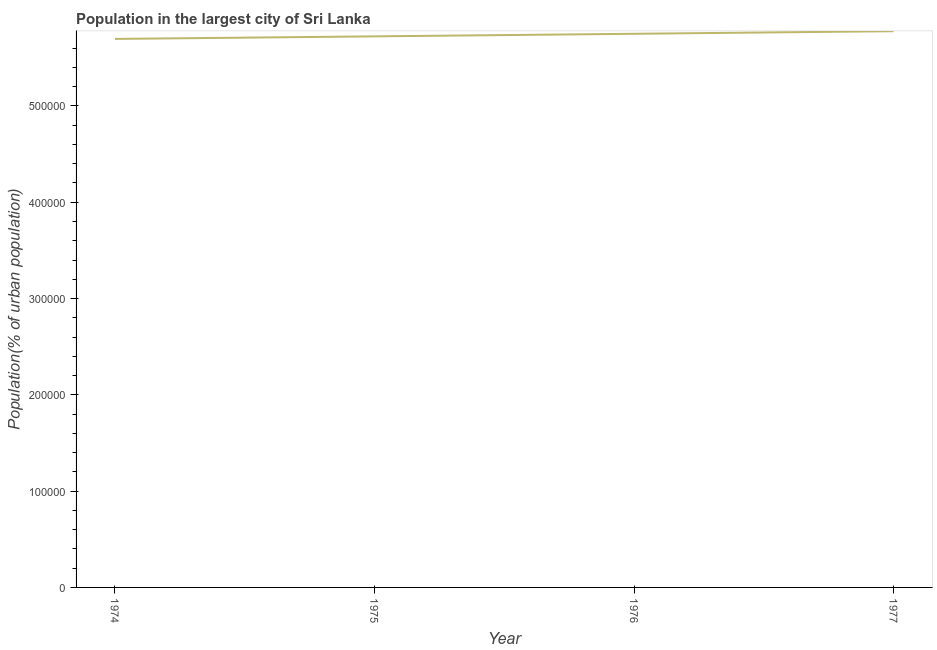What is the population in largest city in 1975?
Give a very brief answer. 5.72e+05. Across all years, what is the maximum population in largest city?
Your answer should be very brief. 5.78e+05. Across all years, what is the minimum population in largest city?
Offer a terse response. 5.70e+05. In which year was the population in largest city minimum?
Offer a terse response. 1974. What is the sum of the population in largest city?
Give a very brief answer. 2.29e+06. What is the difference between the population in largest city in 1975 and 1976?
Offer a very short reply. -2671. What is the average population in largest city per year?
Make the answer very short. 5.74e+05. What is the median population in largest city?
Offer a terse response. 5.74e+05. What is the ratio of the population in largest city in 1974 to that in 1975?
Provide a short and direct response. 1. What is the difference between the highest and the second highest population in largest city?
Offer a terse response. 2676. Is the sum of the population in largest city in 1974 and 1976 greater than the maximum population in largest city across all years?
Provide a short and direct response. Yes. What is the difference between the highest and the lowest population in largest city?
Keep it short and to the point. 8002. How many years are there in the graph?
Give a very brief answer. 4. What is the difference between two consecutive major ticks on the Y-axis?
Keep it short and to the point. 1.00e+05. What is the title of the graph?
Your answer should be very brief. Population in the largest city of Sri Lanka. What is the label or title of the X-axis?
Keep it short and to the point. Year. What is the label or title of the Y-axis?
Provide a succinct answer. Population(% of urban population). What is the Population(% of urban population) of 1974?
Your answer should be very brief. 5.70e+05. What is the Population(% of urban population) of 1975?
Your answer should be very brief. 5.72e+05. What is the Population(% of urban population) in 1976?
Offer a terse response. 5.75e+05. What is the Population(% of urban population) in 1977?
Ensure brevity in your answer.  5.78e+05. What is the difference between the Population(% of urban population) in 1974 and 1975?
Keep it short and to the point. -2655. What is the difference between the Population(% of urban population) in 1974 and 1976?
Offer a very short reply. -5326. What is the difference between the Population(% of urban population) in 1974 and 1977?
Your response must be concise. -8002. What is the difference between the Population(% of urban population) in 1975 and 1976?
Keep it short and to the point. -2671. What is the difference between the Population(% of urban population) in 1975 and 1977?
Keep it short and to the point. -5347. What is the difference between the Population(% of urban population) in 1976 and 1977?
Offer a terse response. -2676. What is the ratio of the Population(% of urban population) in 1974 to that in 1976?
Ensure brevity in your answer.  0.99. What is the ratio of the Population(% of urban population) in 1975 to that in 1977?
Offer a very short reply. 0.99. 